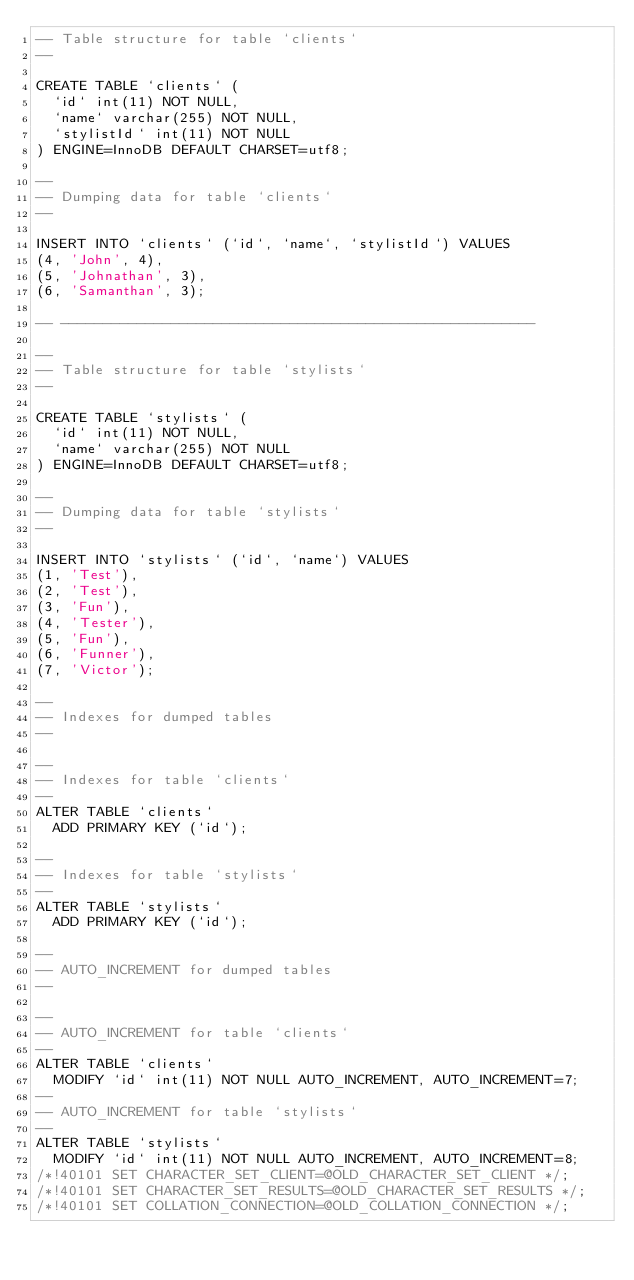Convert code to text. <code><loc_0><loc_0><loc_500><loc_500><_SQL_>-- Table structure for table `clients`
--

CREATE TABLE `clients` (
  `id` int(11) NOT NULL,
  `name` varchar(255) NOT NULL,
  `stylistId` int(11) NOT NULL
) ENGINE=InnoDB DEFAULT CHARSET=utf8;

--
-- Dumping data for table `clients`
--

INSERT INTO `clients` (`id`, `name`, `stylistId`) VALUES
(4, 'John', 4),
(5, 'Johnathan', 3),
(6, 'Samanthan', 3);

-- --------------------------------------------------------

--
-- Table structure for table `stylists`
--

CREATE TABLE `stylists` (
  `id` int(11) NOT NULL,
  `name` varchar(255) NOT NULL
) ENGINE=InnoDB DEFAULT CHARSET=utf8;

--
-- Dumping data for table `stylists`
--

INSERT INTO `stylists` (`id`, `name`) VALUES
(1, 'Test'),
(2, 'Test'),
(3, 'Fun'),
(4, 'Tester'),
(5, 'Fun'),
(6, 'Funner'),
(7, 'Victor');

--
-- Indexes for dumped tables
--

--
-- Indexes for table `clients`
--
ALTER TABLE `clients`
  ADD PRIMARY KEY (`id`);

--
-- Indexes for table `stylists`
--
ALTER TABLE `stylists`
  ADD PRIMARY KEY (`id`);

--
-- AUTO_INCREMENT for dumped tables
--

--
-- AUTO_INCREMENT for table `clients`
--
ALTER TABLE `clients`
  MODIFY `id` int(11) NOT NULL AUTO_INCREMENT, AUTO_INCREMENT=7;
--
-- AUTO_INCREMENT for table `stylists`
--
ALTER TABLE `stylists`
  MODIFY `id` int(11) NOT NULL AUTO_INCREMENT, AUTO_INCREMENT=8;
/*!40101 SET CHARACTER_SET_CLIENT=@OLD_CHARACTER_SET_CLIENT */;
/*!40101 SET CHARACTER_SET_RESULTS=@OLD_CHARACTER_SET_RESULTS */;
/*!40101 SET COLLATION_CONNECTION=@OLD_COLLATION_CONNECTION */;
</code> 